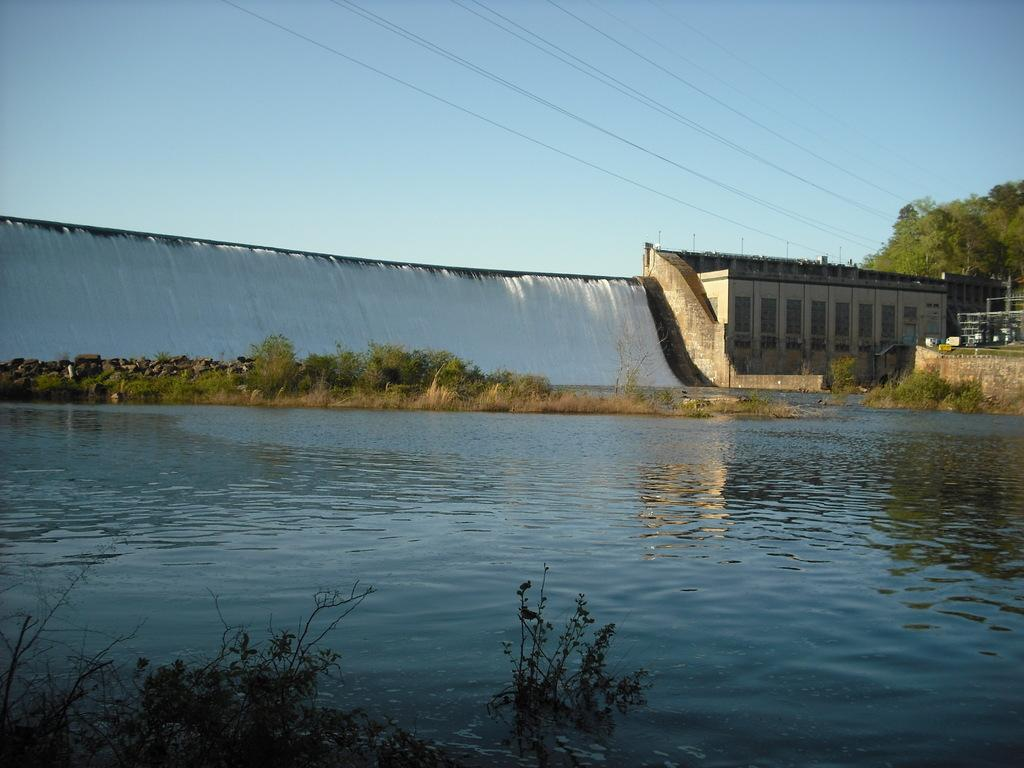What is the source of water flow in the image? There is water flow from dams in the image. Can you describe the water in the image? There is water visible in the image. What type of vegetation is present in the image? There is grass in the image, and there is also a tree. What else can be seen in the image besides water and vegetation? Electric wires are present in the image. How would you describe the color of the sky in the image? The sky has a pale blue color. How many bites does the tree have in the image? There are no bites on the tree in the image; it is a whole tree. Can you tell me how many feet are visible in the image? There are no feet visible in the image; the focus is on the water flow, vegetation, and sky. 